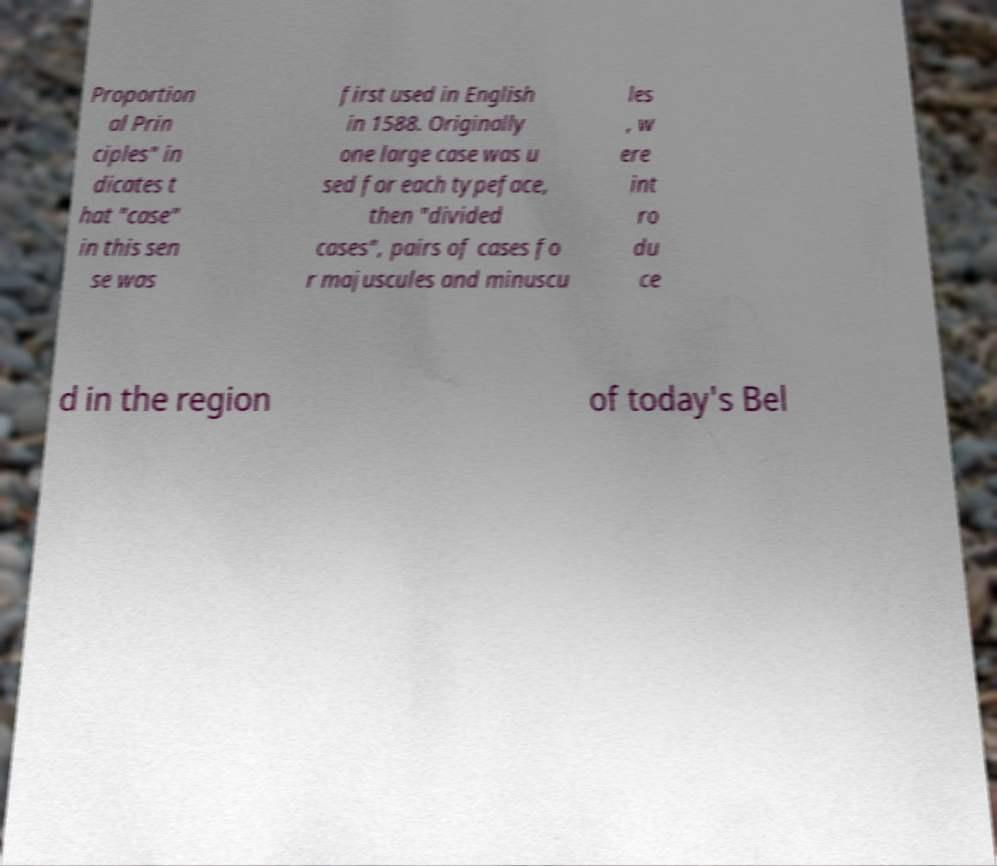Please identify and transcribe the text found in this image. Proportion al Prin ciples" in dicates t hat "case" in this sen se was first used in English in 1588. Originally one large case was u sed for each typeface, then "divided cases", pairs of cases fo r majuscules and minuscu les , w ere int ro du ce d in the region of today's Bel 